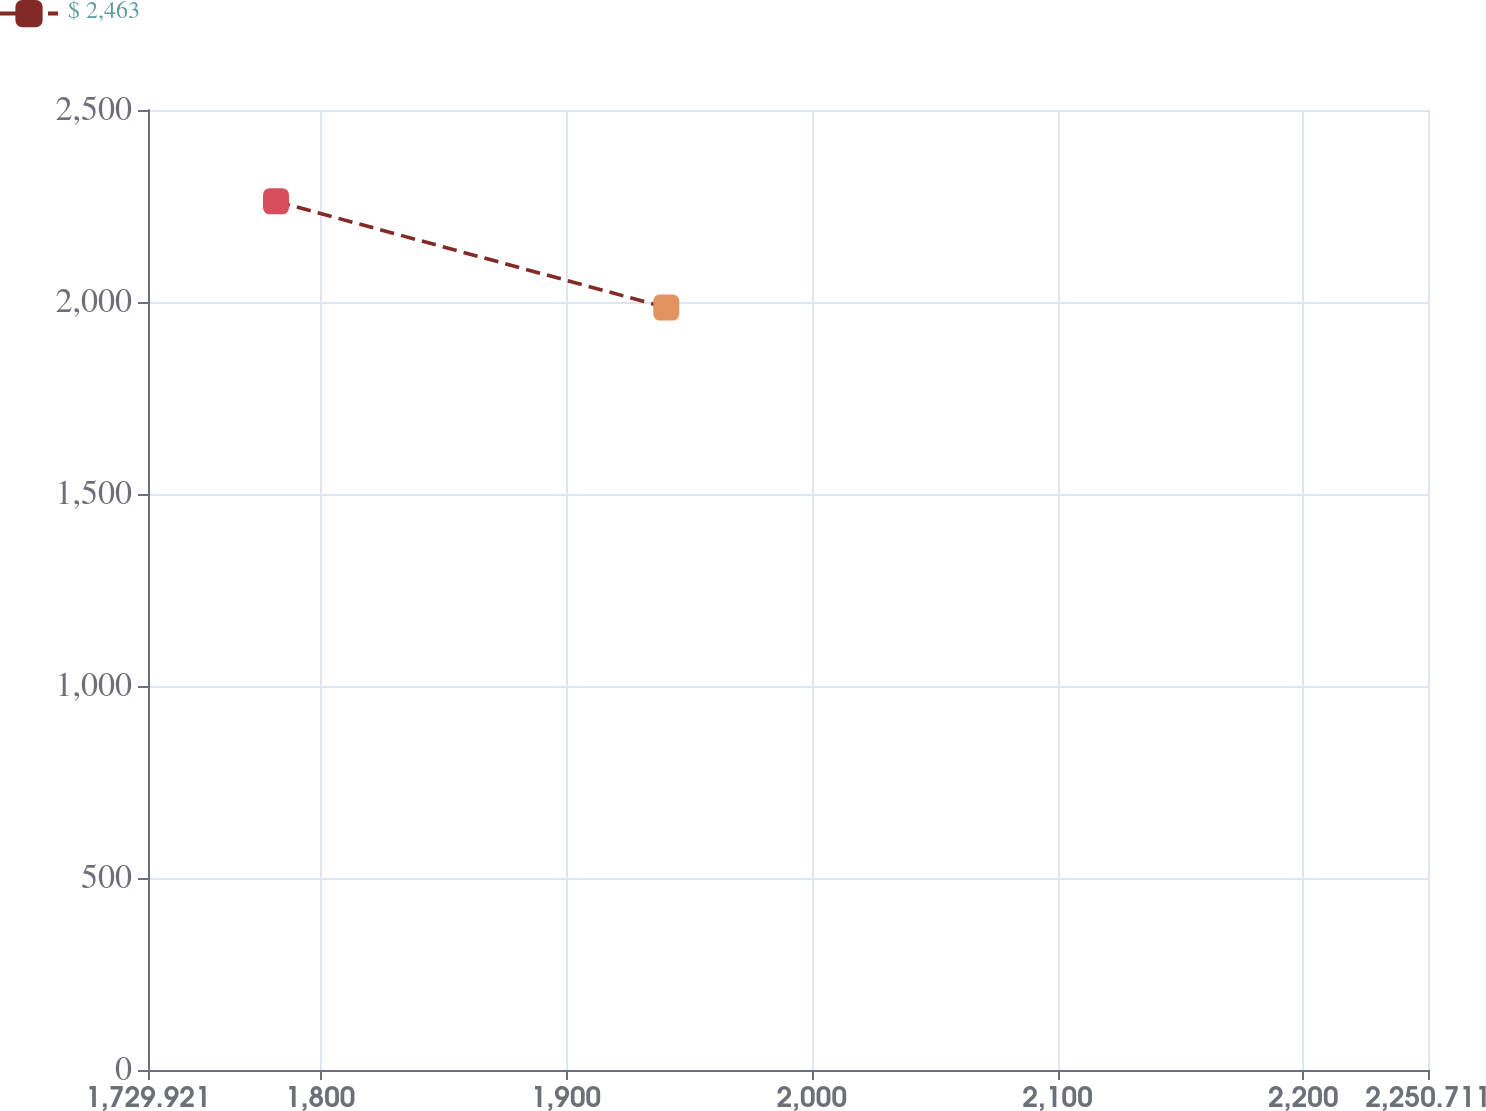<chart> <loc_0><loc_0><loc_500><loc_500><line_chart><ecel><fcel>$ 2,463<nl><fcel>1782<fcel>2262.09<nl><fcel>1940.79<fcel>1985.59<nl><fcel>2254.8<fcel>2171.67<nl><fcel>2302.79<fcel>1298.87<nl></chart> 